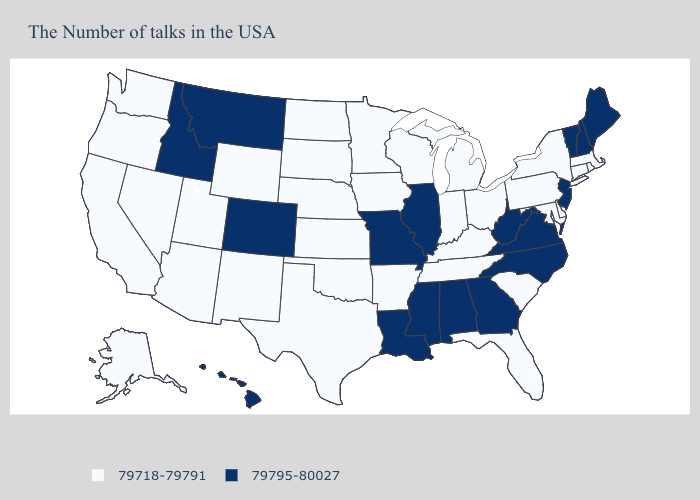What is the value of Louisiana?
Be succinct. 79795-80027. What is the lowest value in states that border Nevada?
Quick response, please. 79718-79791. What is the highest value in the USA?
Be succinct. 79795-80027. What is the highest value in the USA?
Quick response, please. 79795-80027. Does New Hampshire have a higher value than Illinois?
Short answer required. No. Name the states that have a value in the range 79795-80027?
Concise answer only. Maine, New Hampshire, Vermont, New Jersey, Virginia, North Carolina, West Virginia, Georgia, Alabama, Illinois, Mississippi, Louisiana, Missouri, Colorado, Montana, Idaho, Hawaii. Does Wyoming have the same value as Louisiana?
Concise answer only. No. What is the value of North Dakota?
Give a very brief answer. 79718-79791. What is the value of New Mexico?
Give a very brief answer. 79718-79791. Among the states that border Washington , does Oregon have the lowest value?
Concise answer only. Yes. Among the states that border California , which have the highest value?
Write a very short answer. Arizona, Nevada, Oregon. Which states have the lowest value in the Northeast?
Short answer required. Massachusetts, Rhode Island, Connecticut, New York, Pennsylvania. What is the value of Mississippi?
Answer briefly. 79795-80027. Does Illinois have the highest value in the USA?
Write a very short answer. Yes. Which states have the lowest value in the USA?
Short answer required. Massachusetts, Rhode Island, Connecticut, New York, Delaware, Maryland, Pennsylvania, South Carolina, Ohio, Florida, Michigan, Kentucky, Indiana, Tennessee, Wisconsin, Arkansas, Minnesota, Iowa, Kansas, Nebraska, Oklahoma, Texas, South Dakota, North Dakota, Wyoming, New Mexico, Utah, Arizona, Nevada, California, Washington, Oregon, Alaska. 